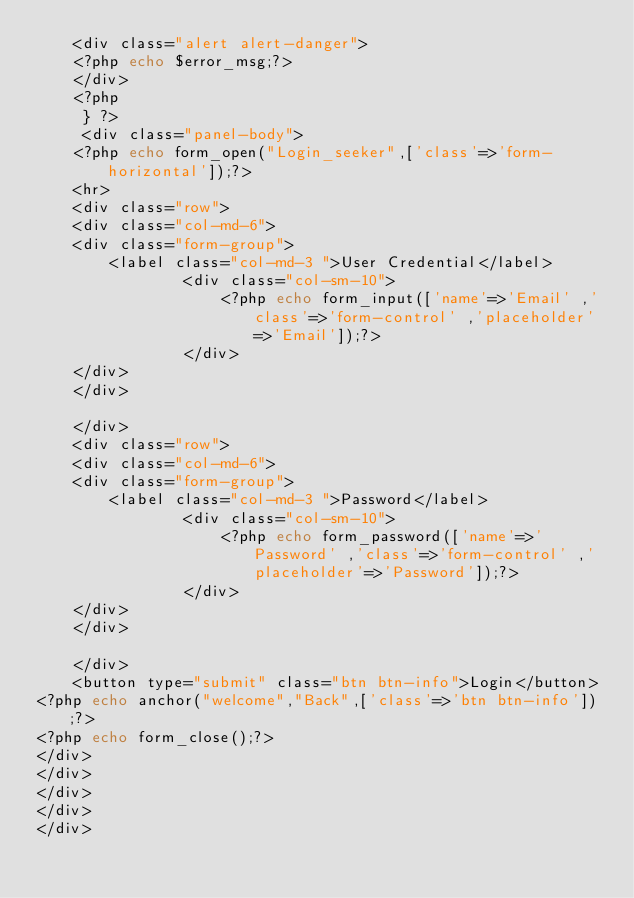Convert code to text. <code><loc_0><loc_0><loc_500><loc_500><_PHP_>	<div class="alert alert-danger">
	<?php echo $error_msg;?>
	</div>
	<?php 
	 } ?>
	 <div class="panel-body">
	<?php echo form_open("Login_seeker",['class'=>'form-horizontal']);?>
	<hr>
	<div class="row">
	<div class="col-md-6">
	<div class="form-group">
		<label class="col-md-3 ">User Credential</label>
				<div class="col-sm-10">
					<?php echo form_input(['name'=>'Email' ,'class'=>'form-control' ,'placeholder'=>'Email']);?>
				</div>
	</div>
	</div>
	
	</div>
	<div class="row">
	<div class="col-md-6">
	<div class="form-group">
		<label class="col-md-3 ">Password</label>
				<div class="col-sm-10">
					<?php echo form_password(['name'=>'Password' ,'class'=>'form-control' ,'placeholder'=>'Password']);?>
				</div>
	</div>
	</div>
	
	</div>
	<button type="submit" class="btn btn-info">Login</button>
<?php echo anchor("welcome","Back",['class'=>'btn btn-info']);?>
<?php echo form_close();?>
</div>
</div>
</div>
</div>
</div></code> 